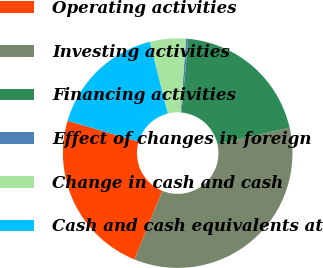<chart> <loc_0><loc_0><loc_500><loc_500><pie_chart><fcel>Operating activities<fcel>Investing activities<fcel>Financing activities<fcel>Effect of changes in foreign<fcel>Change in cash and cash<fcel>Cash and cash equivalents at<nl><fcel>23.41%<fcel>34.71%<fcel>19.97%<fcel>0.32%<fcel>5.07%<fcel>16.53%<nl></chart> 